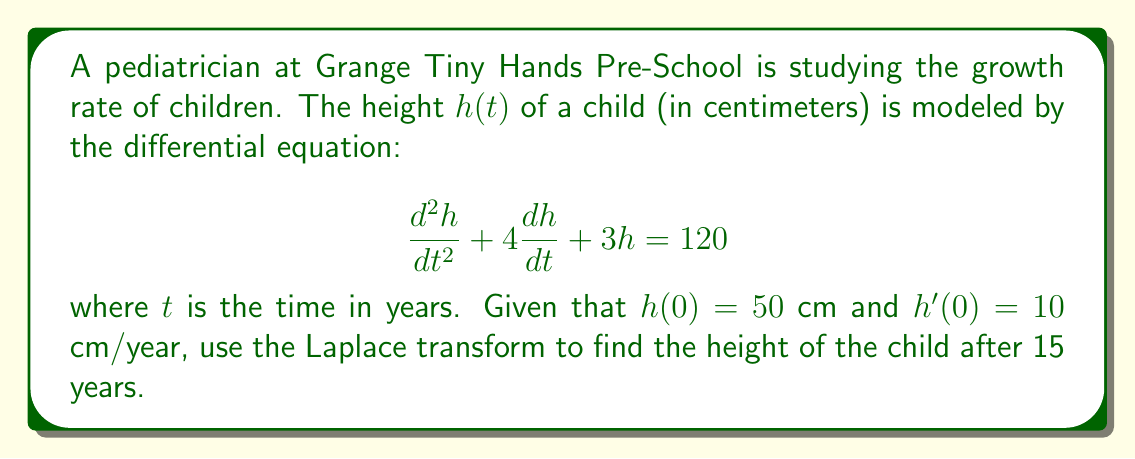Can you answer this question? Let's solve this problem step by step using the Laplace transform:

1) First, let's take the Laplace transform of both sides of the equation:
   
   $$\mathcal{L}\{\frac{d^2h}{dt^2} + 4\frac{dh}{dt} + 3h\} = \mathcal{L}\{120\}$$

2) Using the properties of the Laplace transform:

   $$s^2H(s) - sh(0) - h'(0) + 4(sH(s) - h(0)) + 3H(s) = \frac{120}{s}$$

3) Substitute the initial conditions $h(0) = 50$ and $h'(0) = 10$:

   $$s^2H(s) - 50s - 10 + 4sH(s) - 200 + 3H(s) = \frac{120}{s}$$

4) Simplify:

   $$(s^2 + 4s + 3)H(s) = \frac{120}{s} + 50s + 210$$

5) Solve for $H(s)$:

   $$H(s) = \frac{120/s + 50s + 210}{s^2 + 4s + 3} = \frac{50s^2 + 210s + 120}{s(s^2 + 4s + 3)}$$

6) Use partial fraction decomposition:

   $$H(s) = \frac{A}{s} + \frac{B}{s+1} + \frac{C}{s+3}$$

   Solving for $A$, $B$, and $C$, we get:
   
   $$H(s) = \frac{40}{s} + \frac{20}{s+1} - \frac{10}{s+3}$$

7) Take the inverse Laplace transform:

   $$h(t) = 40 + 20e^{-t} - 10e^{-3t}$$

8) To find the height after 15 years, substitute $t = 15$:

   $$h(15) = 40 + 20e^{-15} - 10e^{-45}$$
Answer: $h(15) \approx 40.00000305$ cm 